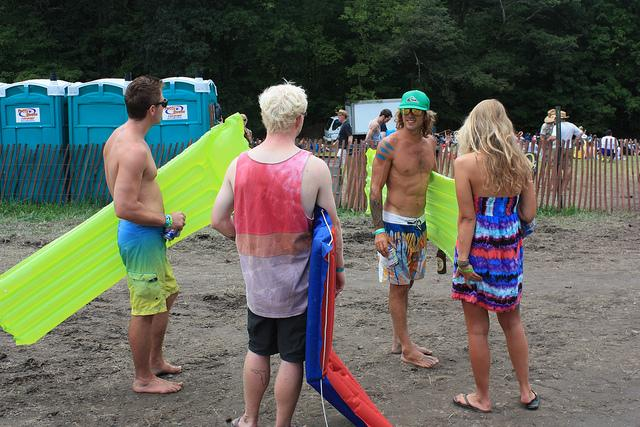Why is the guy's neck red? Please explain your reasoning. sunburn. The guy is outside and tanned, implying he spends a lot of time outside. spending too much time outside on really hot days can lead to sunburns without the proper protection. 